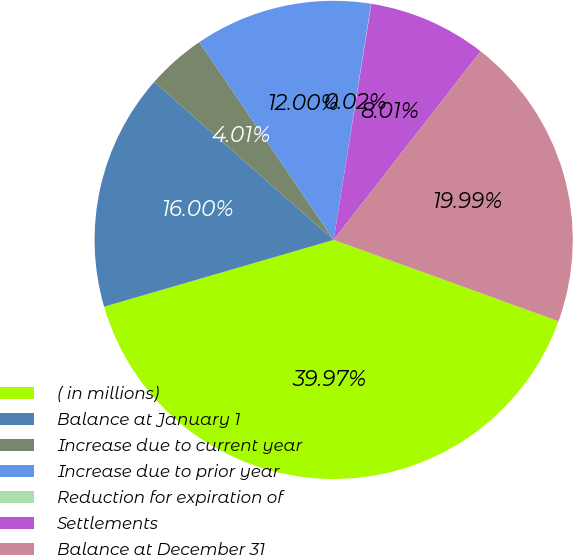Convert chart. <chart><loc_0><loc_0><loc_500><loc_500><pie_chart><fcel>( in millions)<fcel>Balance at January 1<fcel>Increase due to current year<fcel>Increase due to prior year<fcel>Reduction for expiration of<fcel>Settlements<fcel>Balance at December 31<nl><fcel>39.97%<fcel>16.0%<fcel>4.01%<fcel>12.0%<fcel>0.02%<fcel>8.01%<fcel>19.99%<nl></chart> 